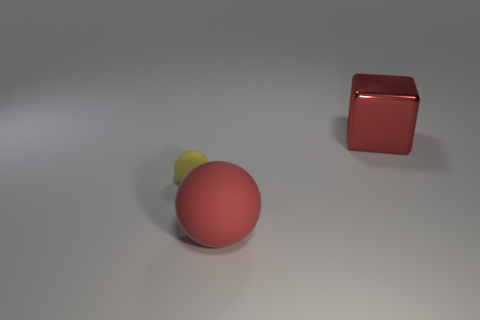Add 1 large gray rubber blocks. How many objects exist? 4 Subtract all cubes. How many objects are left? 2 Add 1 cubes. How many cubes exist? 2 Subtract 0 blue blocks. How many objects are left? 3 Subtract all red rubber balls. Subtract all big cubes. How many objects are left? 1 Add 2 tiny objects. How many tiny objects are left? 3 